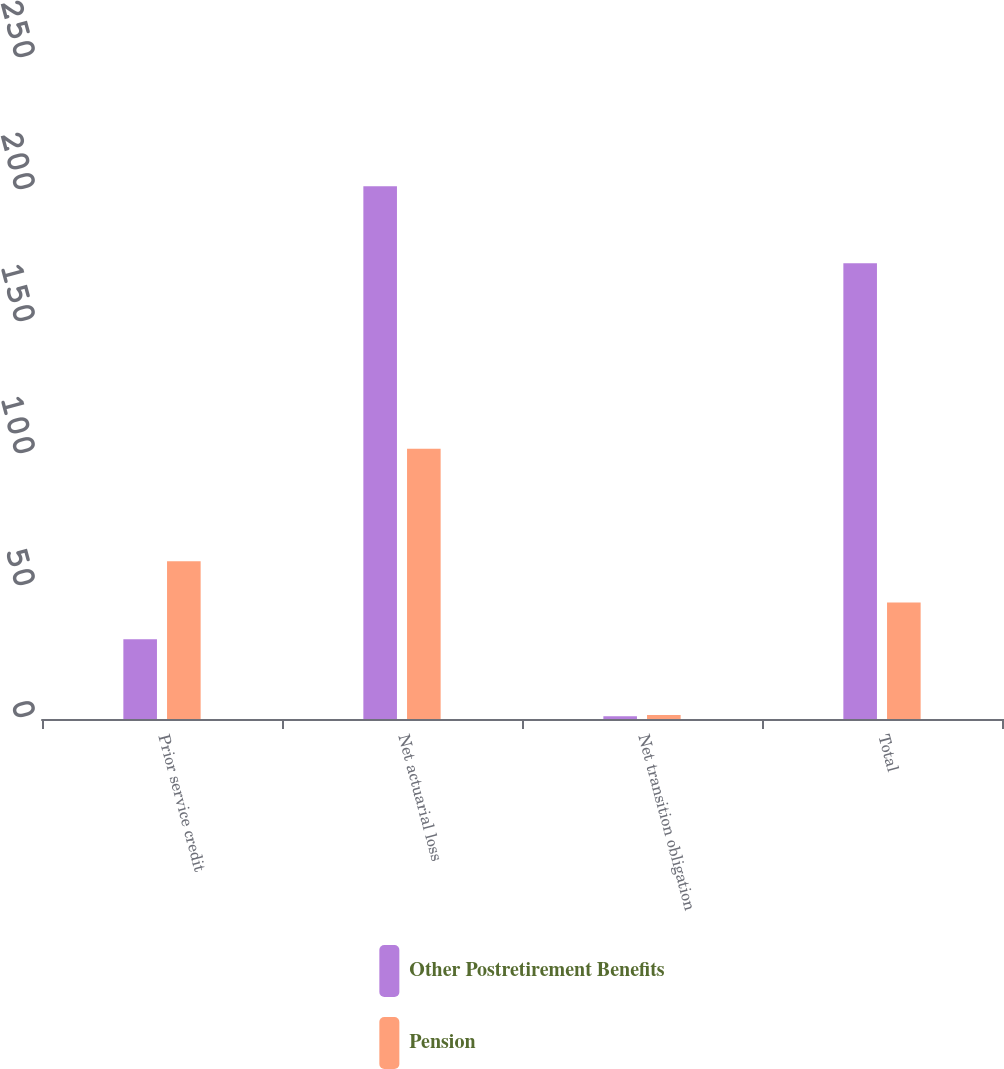<chart> <loc_0><loc_0><loc_500><loc_500><stacked_bar_chart><ecel><fcel>Prior service credit<fcel>Net actuarial loss<fcel>Net transition obligation<fcel>Total<nl><fcel>Other Postretirement Benefits<fcel>30.2<fcel>201.8<fcel>1<fcel>172.6<nl><fcel>Pension<fcel>59.8<fcel>102.4<fcel>1.5<fcel>44.1<nl></chart> 